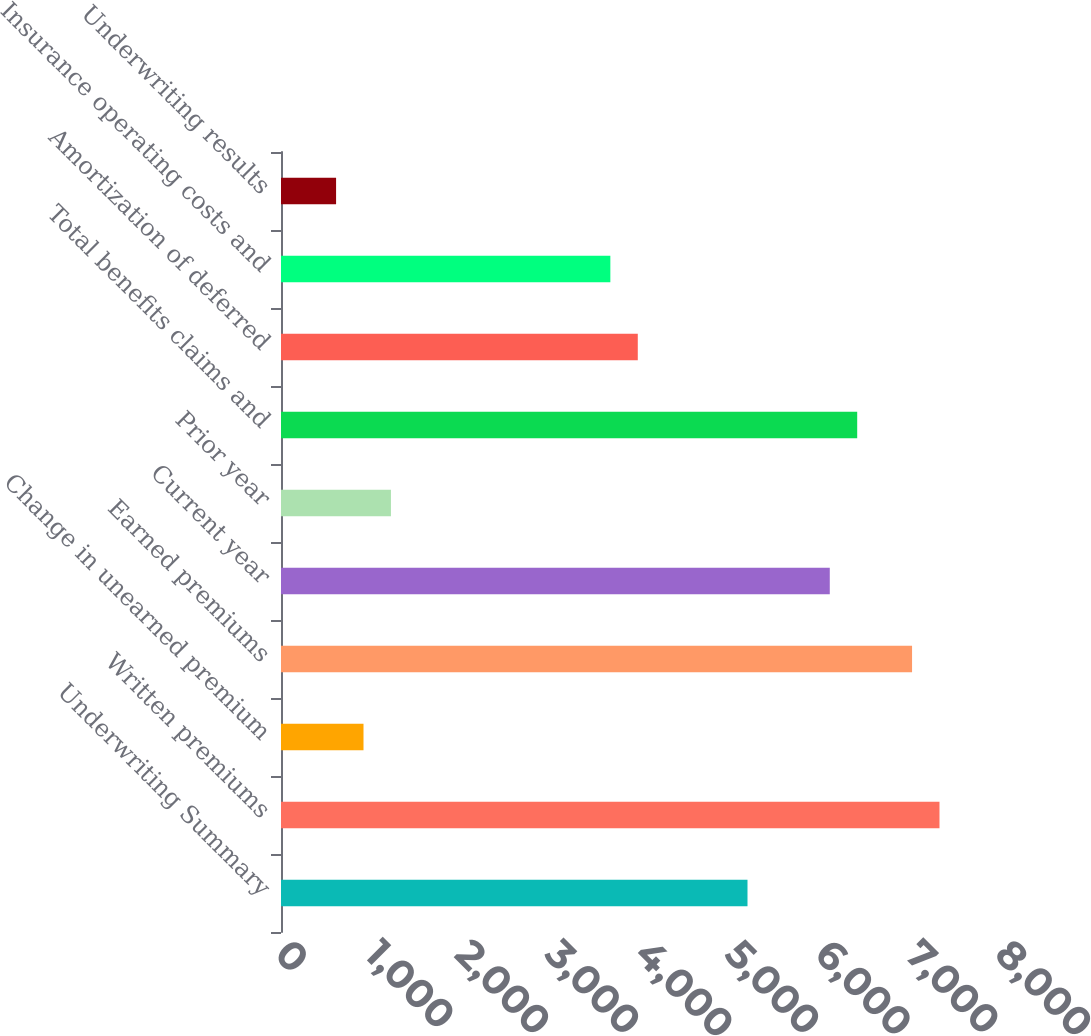<chart> <loc_0><loc_0><loc_500><loc_500><bar_chart><fcel>Underwriting Summary<fcel>Written premiums<fcel>Change in unearned premium<fcel>Earned premiums<fcel>Current year<fcel>Prior year<fcel>Total benefits claims and<fcel>Amortization of deferred<fcel>Insurance operating costs and<fcel>Underwriting results<nl><fcel>5183.25<fcel>7316.5<fcel>916.75<fcel>7011.75<fcel>6097.5<fcel>1221.5<fcel>6402.25<fcel>3964.25<fcel>3659.5<fcel>612<nl></chart> 